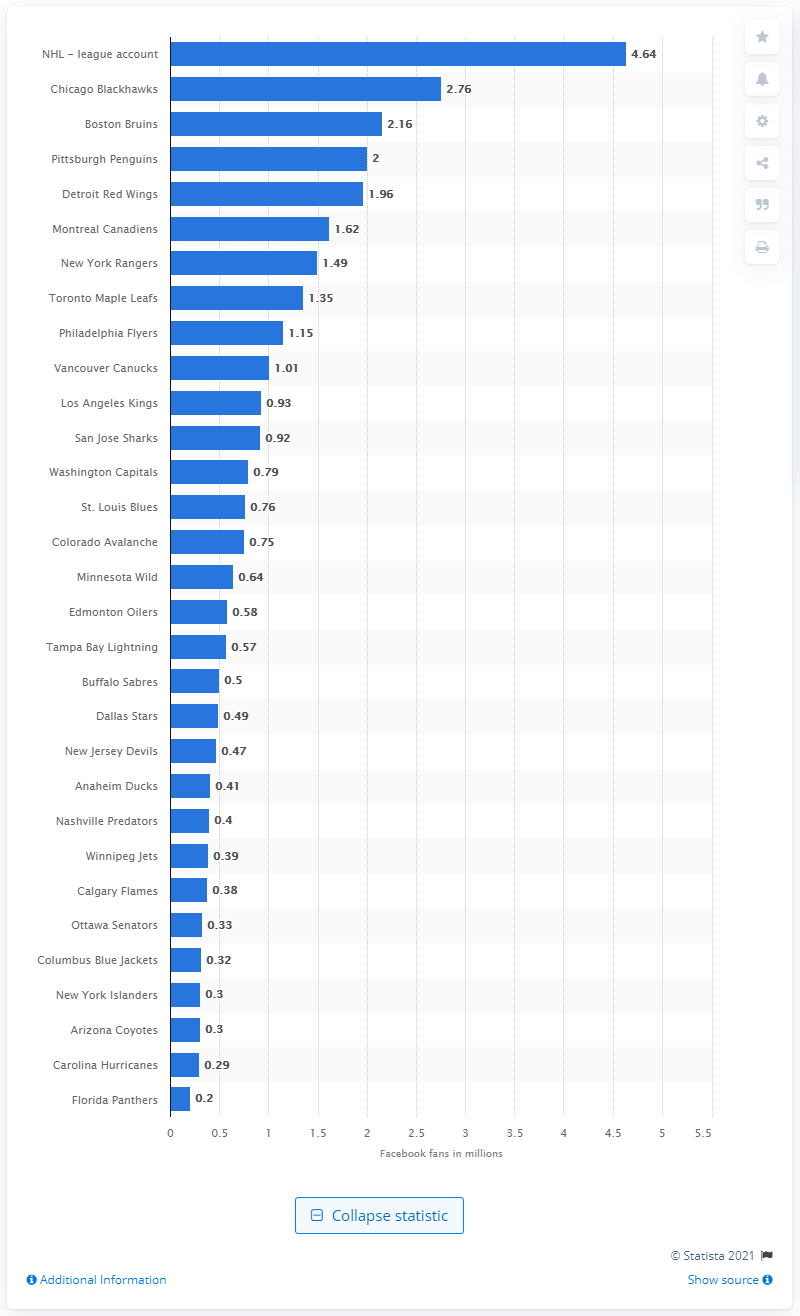Point out several critical features in this image. Chicago Blackhawks have the most followers on Facebook among all teams. The Chicago Blackhawks have 2,760 Facebook fans. The NHL has 4.64 million Facebook fans. 